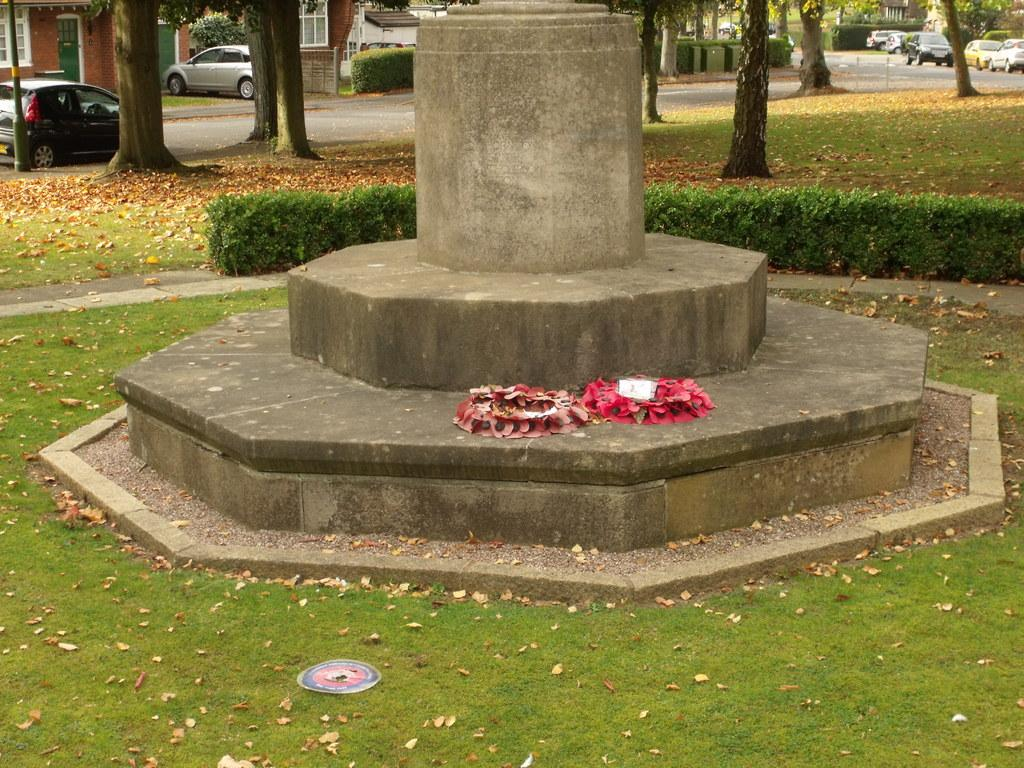What is the main object in the image? There is a foundation stone in the image. Where is the foundation stone located in relation to other objects? The foundation stone is beside some plants. What can be seen in the top left corner of the image? There are stems and cars in the top left corner of the image. What is present in the top right corner of the image? There are stems in the top right corner of the image. What type of throat-soothing remedy is being offered in the image? There is no throat-soothing remedy present in the image; it features a foundation stone, plants, and stems. What is the topic of the argument taking place in the image? There is no argument present in the image; it is a still image featuring a foundation stone, plants, and stems. 